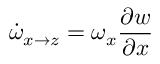<formula> <loc_0><loc_0><loc_500><loc_500>\dot { \omega } _ { x \rightarrow z } = \omega _ { x } \frac { \partial w } { \partial x }</formula> 